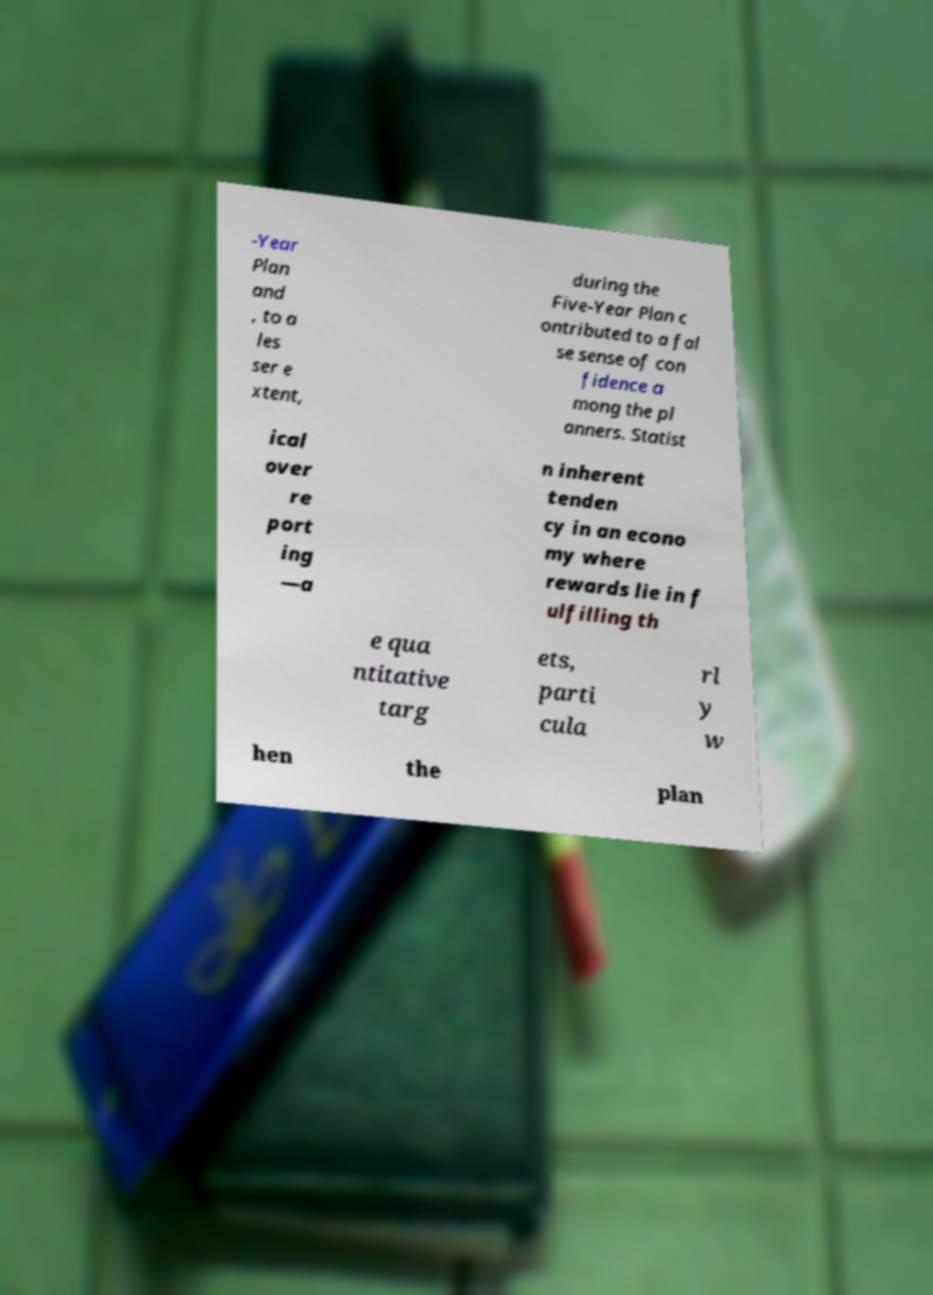What messages or text are displayed in this image? I need them in a readable, typed format. -Year Plan and , to a les ser e xtent, during the Five-Year Plan c ontributed to a fal se sense of con fidence a mong the pl anners. Statist ical over re port ing —a n inherent tenden cy in an econo my where rewards lie in f ulfilling th e qua ntitative targ ets, parti cula rl y w hen the plan 